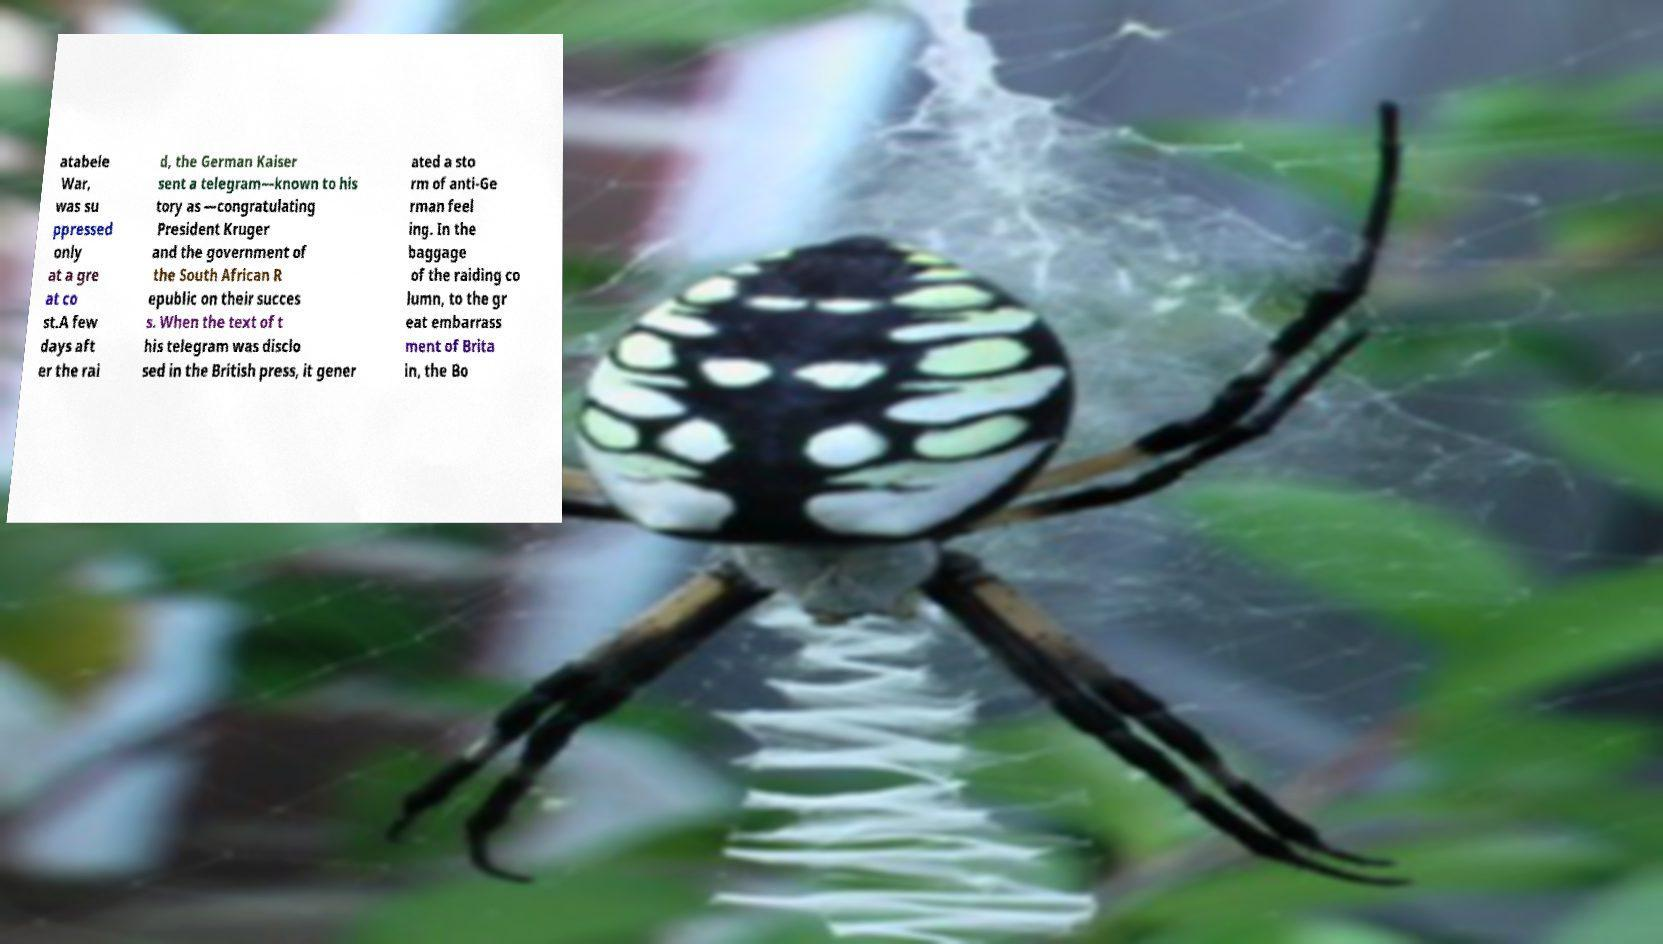I need the written content from this picture converted into text. Can you do that? atabele War, was su ppressed only at a gre at co st.A few days aft er the rai d, the German Kaiser sent a telegram—known to his tory as —congratulating President Kruger and the government of the South African R epublic on their succes s. When the text of t his telegram was disclo sed in the British press, it gener ated a sto rm of anti-Ge rman feel ing. In the baggage of the raiding co lumn, to the gr eat embarrass ment of Brita in, the Bo 